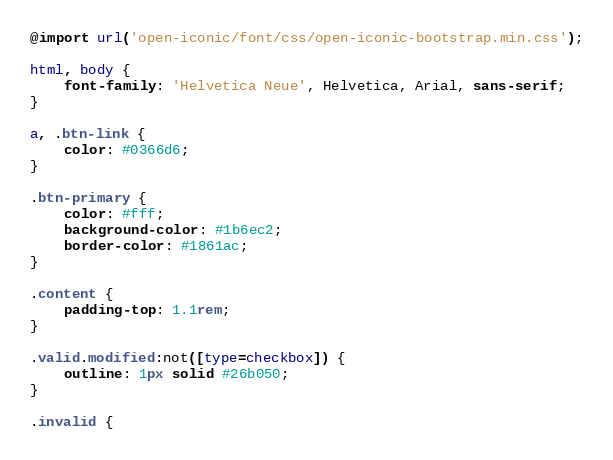<code> <loc_0><loc_0><loc_500><loc_500><_CSS_>@import url('open-iconic/font/css/open-iconic-bootstrap.min.css');

html, body {
    font-family: 'Helvetica Neue', Helvetica, Arial, sans-serif;
}

a, .btn-link {
    color: #0366d6;
}

.btn-primary {
    color: #fff;
    background-color: #1b6ec2;
    border-color: #1861ac;
}

.content {
    padding-top: 1.1rem;
}

.valid.modified:not([type=checkbox]) {
    outline: 1px solid #26b050;
}

.invalid {</code> 